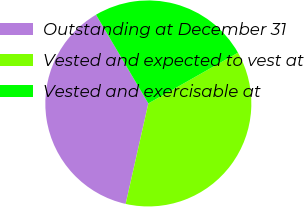Convert chart. <chart><loc_0><loc_0><loc_500><loc_500><pie_chart><fcel>Outstanding at December 31<fcel>Vested and expected to vest at<fcel>Vested and exercisable at<nl><fcel>37.99%<fcel>36.73%<fcel>25.28%<nl></chart> 